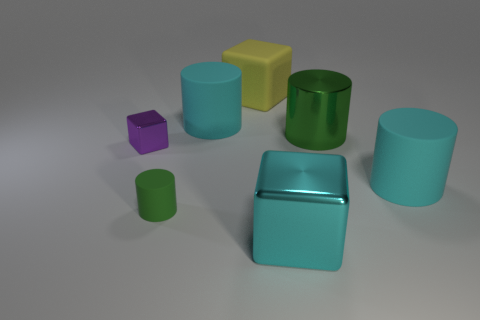Subtract all tiny matte cylinders. How many cylinders are left? 3 Subtract all cyan balls. How many cyan cylinders are left? 2 Subtract all cyan cylinders. How many cylinders are left? 2 Add 1 large purple metallic cylinders. How many objects exist? 8 Subtract all cylinders. How many objects are left? 3 Subtract all blue cylinders. Subtract all red cubes. How many cylinders are left? 4 Subtract 0 cyan balls. How many objects are left? 7 Subtract all purple cubes. Subtract all green cubes. How many objects are left? 6 Add 1 big cyan metal things. How many big cyan metal things are left? 2 Add 7 large green metallic things. How many large green metallic things exist? 8 